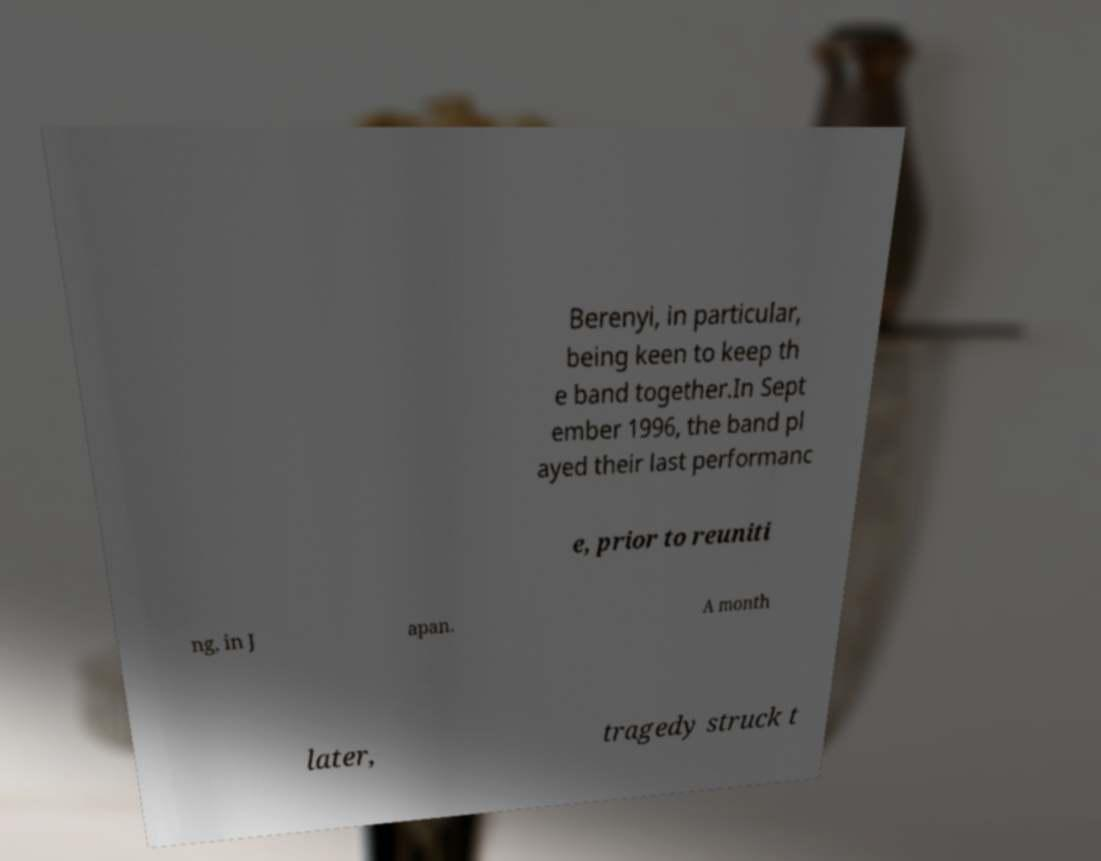Can you read and provide the text displayed in the image?This photo seems to have some interesting text. Can you extract and type it out for me? Berenyi, in particular, being keen to keep th e band together.In Sept ember 1996, the band pl ayed their last performanc e, prior to reuniti ng, in J apan. A month later, tragedy struck t 